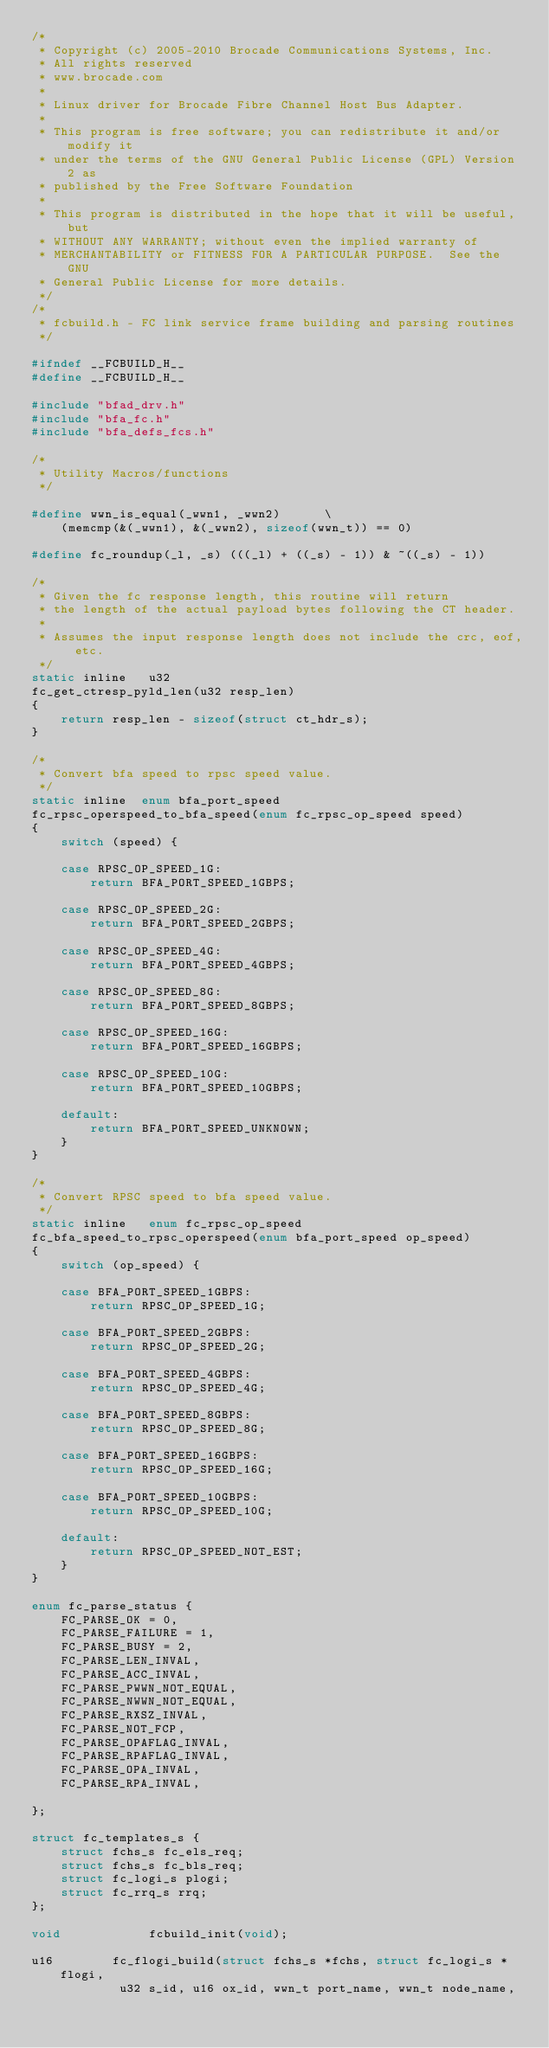<code> <loc_0><loc_0><loc_500><loc_500><_C_>/*
 * Copyright (c) 2005-2010 Brocade Communications Systems, Inc.
 * All rights reserved
 * www.brocade.com
 *
 * Linux driver for Brocade Fibre Channel Host Bus Adapter.
 *
 * This program is free software; you can redistribute it and/or modify it
 * under the terms of the GNU General Public License (GPL) Version 2 as
 * published by the Free Software Foundation
 *
 * This program is distributed in the hope that it will be useful, but
 * WITHOUT ANY WARRANTY; without even the implied warranty of
 * MERCHANTABILITY or FITNESS FOR A PARTICULAR PURPOSE.  See the GNU
 * General Public License for more details.
 */
/*
 * fcbuild.h - FC link service frame building and parsing routines
 */

#ifndef __FCBUILD_H__
#define __FCBUILD_H__

#include "bfad_drv.h"
#include "bfa_fc.h"
#include "bfa_defs_fcs.h"

/*
 * Utility Macros/functions
 */

#define wwn_is_equal(_wwn1, _wwn2)		\
	(memcmp(&(_wwn1), &(_wwn2), sizeof(wwn_t)) == 0)

#define fc_roundup(_l, _s) (((_l) + ((_s) - 1)) & ~((_s) - 1))

/*
 * Given the fc response length, this routine will return
 * the length of the actual payload bytes following the CT header.
 *
 * Assumes the input response length does not include the crc, eof, etc.
 */
static inline   u32
fc_get_ctresp_pyld_len(u32 resp_len)
{
	return resp_len - sizeof(struct ct_hdr_s);
}

/*
 * Convert bfa speed to rpsc speed value.
 */
static inline  enum bfa_port_speed
fc_rpsc_operspeed_to_bfa_speed(enum fc_rpsc_op_speed speed)
{
	switch (speed) {

	case RPSC_OP_SPEED_1G:
		return BFA_PORT_SPEED_1GBPS;

	case RPSC_OP_SPEED_2G:
		return BFA_PORT_SPEED_2GBPS;

	case RPSC_OP_SPEED_4G:
		return BFA_PORT_SPEED_4GBPS;

	case RPSC_OP_SPEED_8G:
		return BFA_PORT_SPEED_8GBPS;

	case RPSC_OP_SPEED_16G:
		return BFA_PORT_SPEED_16GBPS;

	case RPSC_OP_SPEED_10G:
		return BFA_PORT_SPEED_10GBPS;

	default:
		return BFA_PORT_SPEED_UNKNOWN;
	}
}

/*
 * Convert RPSC speed to bfa speed value.
 */
static inline   enum fc_rpsc_op_speed
fc_bfa_speed_to_rpsc_operspeed(enum bfa_port_speed op_speed)
{
	switch (op_speed) {

	case BFA_PORT_SPEED_1GBPS:
		return RPSC_OP_SPEED_1G;

	case BFA_PORT_SPEED_2GBPS:
		return RPSC_OP_SPEED_2G;

	case BFA_PORT_SPEED_4GBPS:
		return RPSC_OP_SPEED_4G;

	case BFA_PORT_SPEED_8GBPS:
		return RPSC_OP_SPEED_8G;

	case BFA_PORT_SPEED_16GBPS:
		return RPSC_OP_SPEED_16G;

	case BFA_PORT_SPEED_10GBPS:
		return RPSC_OP_SPEED_10G;

	default:
		return RPSC_OP_SPEED_NOT_EST;
	}
}

enum fc_parse_status {
	FC_PARSE_OK = 0,
	FC_PARSE_FAILURE = 1,
	FC_PARSE_BUSY = 2,
	FC_PARSE_LEN_INVAL,
	FC_PARSE_ACC_INVAL,
	FC_PARSE_PWWN_NOT_EQUAL,
	FC_PARSE_NWWN_NOT_EQUAL,
	FC_PARSE_RXSZ_INVAL,
	FC_PARSE_NOT_FCP,
	FC_PARSE_OPAFLAG_INVAL,
	FC_PARSE_RPAFLAG_INVAL,
	FC_PARSE_OPA_INVAL,
	FC_PARSE_RPA_INVAL,

};

struct fc_templates_s {
	struct fchs_s fc_els_req;
	struct fchs_s fc_bls_req;
	struct fc_logi_s plogi;
	struct fc_rrq_s rrq;
};

void            fcbuild_init(void);

u16        fc_flogi_build(struct fchs_s *fchs, struct fc_logi_s *flogi,
			u32 s_id, u16 ox_id, wwn_t port_name, wwn_t node_name,</code> 